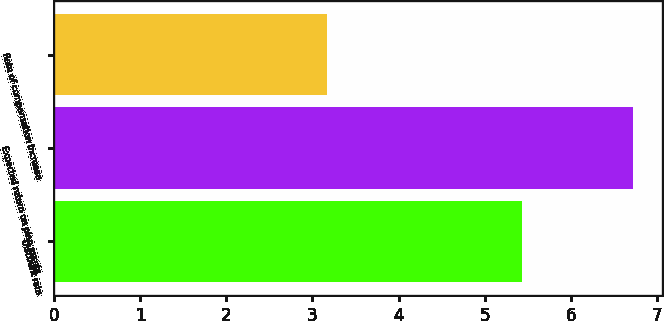Convert chart. <chart><loc_0><loc_0><loc_500><loc_500><bar_chart><fcel>Discount rate<fcel>Expected return on plan assets<fcel>Rate of compensation increase<nl><fcel>5.43<fcel>6.72<fcel>3.17<nl></chart> 